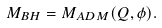Convert formula to latex. <formula><loc_0><loc_0><loc_500><loc_500>M _ { B H } = M _ { A D M } ( Q , \phi ) .</formula> 